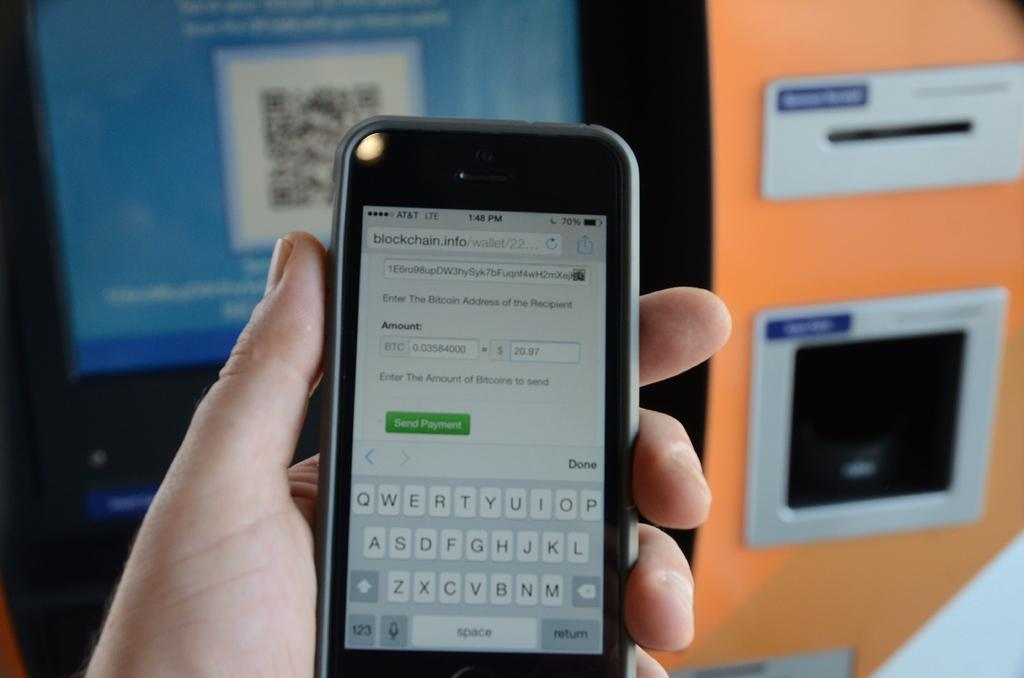<image>
Describe the image concisely. The time is currently 148 on the black phone 